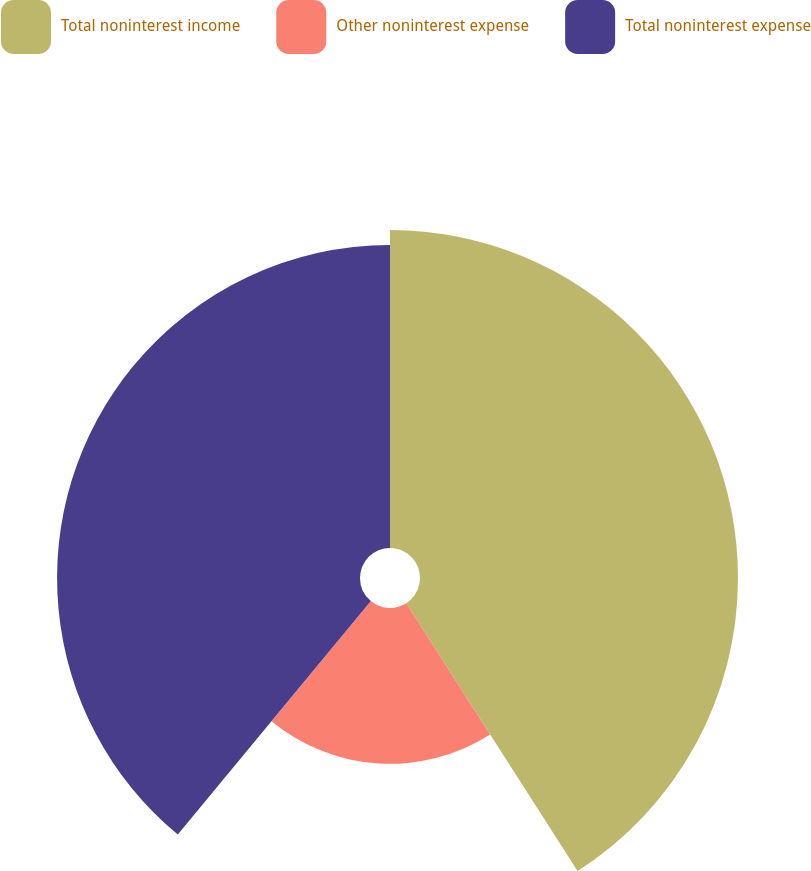Convert chart to OTSL. <chart><loc_0><loc_0><loc_500><loc_500><pie_chart><fcel>Total noninterest income<fcel>Other noninterest expense<fcel>Total noninterest expense<nl><fcel>40.94%<fcel>20.06%<fcel>39.0%<nl></chart> 